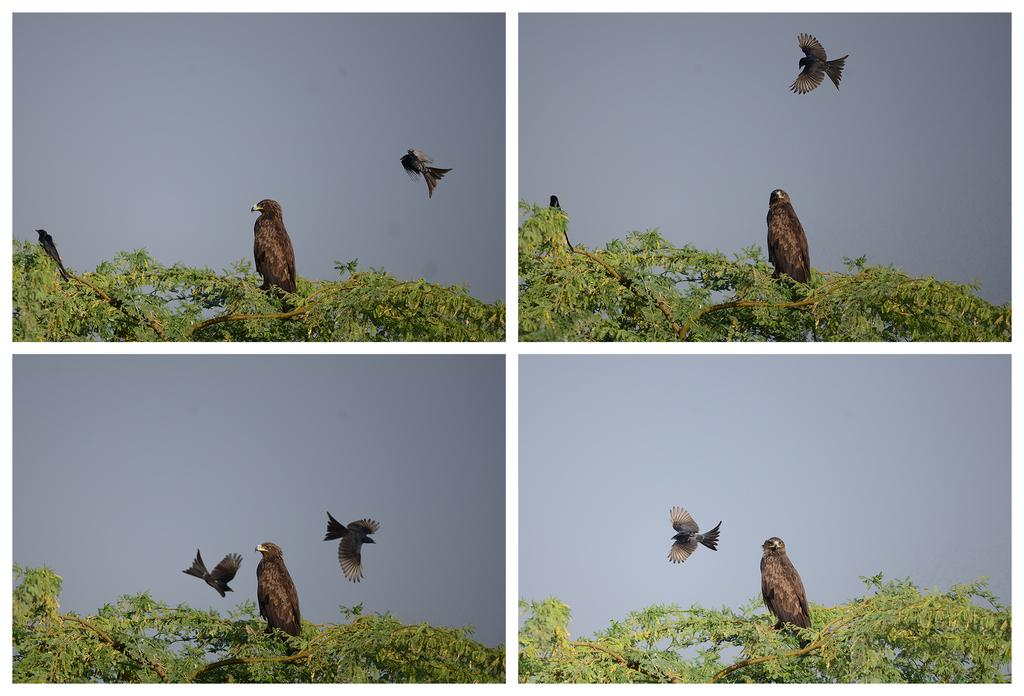What type of animals can be seen in the image? There are birds in the image. Where are the birds located? The birds are on trees. What is visible at the top of the image? The sky is visible at the top of the image. How is the image composed? The image is a collage. What type of nerve can be seen in the image? There is no nerve present in the image; it features birds on trees and a visible sky. 